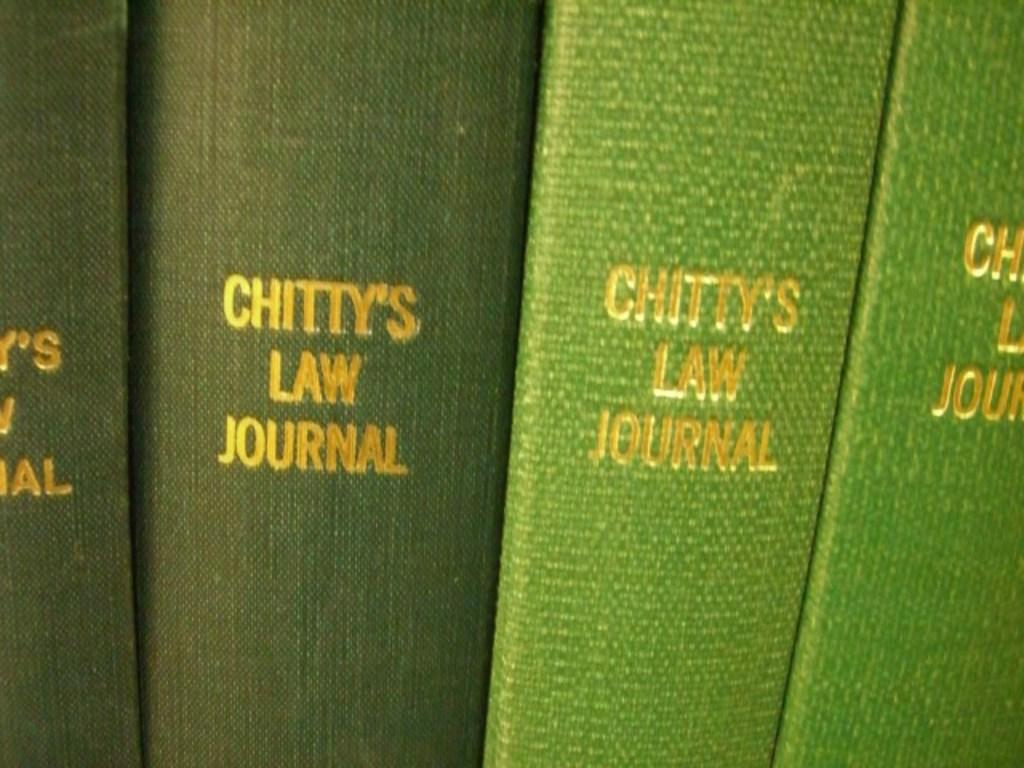<image>
Provide a brief description of the given image. Various old bound books that are green in color and say Chitty's law Journal. 